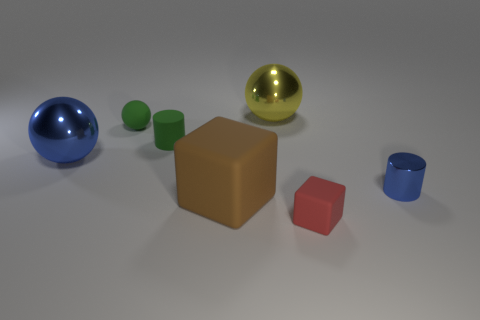Subtract all big balls. How many balls are left? 1 Add 2 large yellow metal spheres. How many objects exist? 9 Subtract all cylinders. How many objects are left? 5 Add 7 red rubber things. How many red rubber things exist? 8 Subtract 0 purple spheres. How many objects are left? 7 Subtract all small cyan rubber things. Subtract all yellow spheres. How many objects are left? 6 Add 4 shiny cylinders. How many shiny cylinders are left? 5 